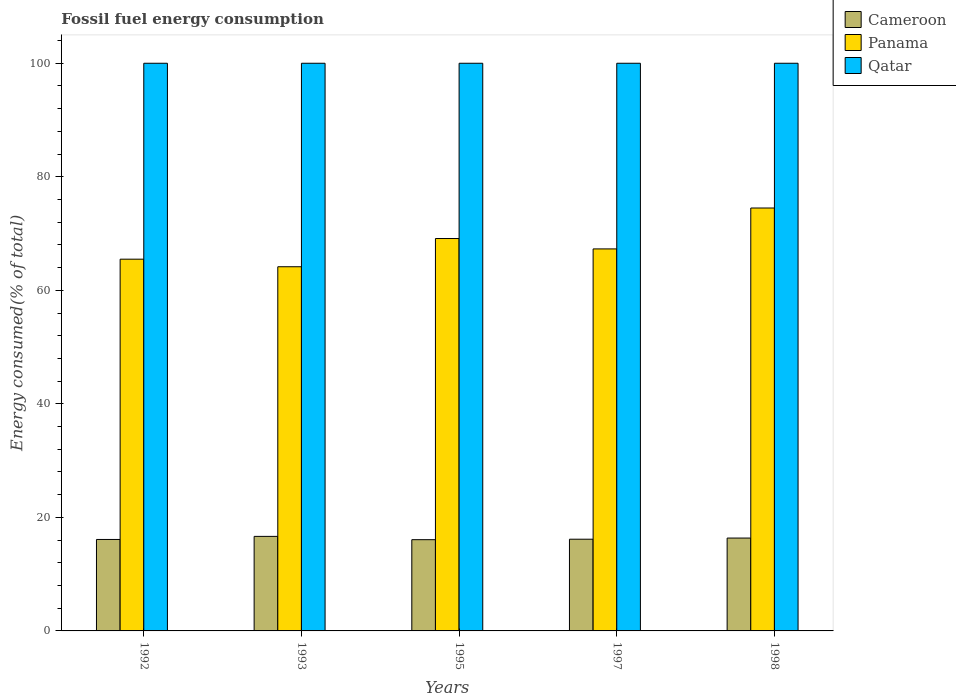Are the number of bars per tick equal to the number of legend labels?
Provide a short and direct response. Yes. Are the number of bars on each tick of the X-axis equal?
Offer a very short reply. Yes. What is the percentage of energy consumed in Panama in 1992?
Keep it short and to the point. 65.49. Across all years, what is the maximum percentage of energy consumed in Qatar?
Provide a succinct answer. 100. Across all years, what is the minimum percentage of energy consumed in Panama?
Provide a short and direct response. 64.15. In which year was the percentage of energy consumed in Qatar minimum?
Offer a very short reply. 1992. What is the total percentage of energy consumed in Panama in the graph?
Offer a terse response. 340.56. What is the difference between the percentage of energy consumed in Qatar in 1993 and that in 1997?
Ensure brevity in your answer.  -2.934021892997407e-6. What is the difference between the percentage of energy consumed in Cameroon in 1998 and the percentage of energy consumed in Panama in 1995?
Your answer should be very brief. -52.77. What is the average percentage of energy consumed in Panama per year?
Ensure brevity in your answer.  68.11. In the year 1995, what is the difference between the percentage of energy consumed in Panama and percentage of energy consumed in Cameroon?
Make the answer very short. 53.05. What is the ratio of the percentage of energy consumed in Panama in 1992 to that in 1993?
Make the answer very short. 1.02. Is the difference between the percentage of energy consumed in Panama in 1995 and 1997 greater than the difference between the percentage of energy consumed in Cameroon in 1995 and 1997?
Offer a terse response. Yes. What is the difference between the highest and the second highest percentage of energy consumed in Panama?
Make the answer very short. 5.37. What is the difference between the highest and the lowest percentage of energy consumed in Qatar?
Your answer should be very brief. 1.3242568797977583e-5. What does the 3rd bar from the left in 1995 represents?
Your answer should be compact. Qatar. What does the 2nd bar from the right in 1993 represents?
Offer a very short reply. Panama. Are all the bars in the graph horizontal?
Your response must be concise. No. Does the graph contain any zero values?
Your answer should be very brief. No. Does the graph contain grids?
Keep it short and to the point. No. Where does the legend appear in the graph?
Your answer should be compact. Top right. How many legend labels are there?
Make the answer very short. 3. What is the title of the graph?
Your answer should be very brief. Fossil fuel energy consumption. Does "Uruguay" appear as one of the legend labels in the graph?
Make the answer very short. No. What is the label or title of the X-axis?
Your response must be concise. Years. What is the label or title of the Y-axis?
Offer a terse response. Energy consumed(% of total). What is the Energy consumed(% of total) of Cameroon in 1992?
Your answer should be compact. 16.11. What is the Energy consumed(% of total) of Panama in 1992?
Offer a very short reply. 65.49. What is the Energy consumed(% of total) in Qatar in 1992?
Offer a very short reply. 100. What is the Energy consumed(% of total) of Cameroon in 1993?
Provide a short and direct response. 16.65. What is the Energy consumed(% of total) of Panama in 1993?
Your response must be concise. 64.15. What is the Energy consumed(% of total) in Qatar in 1993?
Your answer should be very brief. 100. What is the Energy consumed(% of total) in Cameroon in 1995?
Your response must be concise. 16.07. What is the Energy consumed(% of total) in Panama in 1995?
Make the answer very short. 69.13. What is the Energy consumed(% of total) of Qatar in 1995?
Your answer should be compact. 100. What is the Energy consumed(% of total) in Cameroon in 1997?
Your answer should be very brief. 16.15. What is the Energy consumed(% of total) in Panama in 1997?
Offer a terse response. 67.3. What is the Energy consumed(% of total) in Qatar in 1997?
Give a very brief answer. 100. What is the Energy consumed(% of total) of Cameroon in 1998?
Offer a very short reply. 16.36. What is the Energy consumed(% of total) in Panama in 1998?
Your response must be concise. 74.5. Across all years, what is the maximum Energy consumed(% of total) of Cameroon?
Offer a very short reply. 16.65. Across all years, what is the maximum Energy consumed(% of total) of Panama?
Keep it short and to the point. 74.5. Across all years, what is the maximum Energy consumed(% of total) of Qatar?
Offer a very short reply. 100. Across all years, what is the minimum Energy consumed(% of total) of Cameroon?
Your answer should be compact. 16.07. Across all years, what is the minimum Energy consumed(% of total) of Panama?
Your answer should be compact. 64.15. Across all years, what is the minimum Energy consumed(% of total) in Qatar?
Offer a very short reply. 100. What is the total Energy consumed(% of total) of Cameroon in the graph?
Your answer should be very brief. 81.35. What is the total Energy consumed(% of total) in Panama in the graph?
Provide a short and direct response. 340.56. What is the difference between the Energy consumed(% of total) of Cameroon in 1992 and that in 1993?
Keep it short and to the point. -0.54. What is the difference between the Energy consumed(% of total) of Panama in 1992 and that in 1993?
Ensure brevity in your answer.  1.33. What is the difference between the Energy consumed(% of total) of Cameroon in 1992 and that in 1995?
Give a very brief answer. 0.04. What is the difference between the Energy consumed(% of total) in Panama in 1992 and that in 1995?
Your answer should be very brief. -3.64. What is the difference between the Energy consumed(% of total) of Qatar in 1992 and that in 1995?
Offer a terse response. -0. What is the difference between the Energy consumed(% of total) of Cameroon in 1992 and that in 1997?
Offer a terse response. -0.04. What is the difference between the Energy consumed(% of total) of Panama in 1992 and that in 1997?
Offer a terse response. -1.81. What is the difference between the Energy consumed(% of total) in Cameroon in 1992 and that in 1998?
Your response must be concise. -0.25. What is the difference between the Energy consumed(% of total) in Panama in 1992 and that in 1998?
Keep it short and to the point. -9.01. What is the difference between the Energy consumed(% of total) of Qatar in 1992 and that in 1998?
Ensure brevity in your answer.  -0. What is the difference between the Energy consumed(% of total) in Cameroon in 1993 and that in 1995?
Provide a succinct answer. 0.58. What is the difference between the Energy consumed(% of total) in Panama in 1993 and that in 1995?
Your response must be concise. -4.97. What is the difference between the Energy consumed(% of total) of Cameroon in 1993 and that in 1997?
Ensure brevity in your answer.  0.5. What is the difference between the Energy consumed(% of total) of Panama in 1993 and that in 1997?
Make the answer very short. -3.14. What is the difference between the Energy consumed(% of total) in Qatar in 1993 and that in 1997?
Your answer should be compact. -0. What is the difference between the Energy consumed(% of total) in Cameroon in 1993 and that in 1998?
Your answer should be compact. 0.29. What is the difference between the Energy consumed(% of total) in Panama in 1993 and that in 1998?
Provide a short and direct response. -10.35. What is the difference between the Energy consumed(% of total) of Qatar in 1993 and that in 1998?
Make the answer very short. -0. What is the difference between the Energy consumed(% of total) of Cameroon in 1995 and that in 1997?
Your response must be concise. -0.08. What is the difference between the Energy consumed(% of total) in Panama in 1995 and that in 1997?
Provide a succinct answer. 1.83. What is the difference between the Energy consumed(% of total) of Cameroon in 1995 and that in 1998?
Provide a short and direct response. -0.29. What is the difference between the Energy consumed(% of total) in Panama in 1995 and that in 1998?
Provide a short and direct response. -5.37. What is the difference between the Energy consumed(% of total) of Cameroon in 1997 and that in 1998?
Offer a very short reply. -0.21. What is the difference between the Energy consumed(% of total) in Panama in 1997 and that in 1998?
Your answer should be compact. -7.2. What is the difference between the Energy consumed(% of total) of Cameroon in 1992 and the Energy consumed(% of total) of Panama in 1993?
Offer a terse response. -48.04. What is the difference between the Energy consumed(% of total) of Cameroon in 1992 and the Energy consumed(% of total) of Qatar in 1993?
Keep it short and to the point. -83.89. What is the difference between the Energy consumed(% of total) in Panama in 1992 and the Energy consumed(% of total) in Qatar in 1993?
Make the answer very short. -34.51. What is the difference between the Energy consumed(% of total) in Cameroon in 1992 and the Energy consumed(% of total) in Panama in 1995?
Ensure brevity in your answer.  -53.02. What is the difference between the Energy consumed(% of total) of Cameroon in 1992 and the Energy consumed(% of total) of Qatar in 1995?
Offer a terse response. -83.89. What is the difference between the Energy consumed(% of total) of Panama in 1992 and the Energy consumed(% of total) of Qatar in 1995?
Give a very brief answer. -34.51. What is the difference between the Energy consumed(% of total) in Cameroon in 1992 and the Energy consumed(% of total) in Panama in 1997?
Offer a terse response. -51.19. What is the difference between the Energy consumed(% of total) of Cameroon in 1992 and the Energy consumed(% of total) of Qatar in 1997?
Your response must be concise. -83.89. What is the difference between the Energy consumed(% of total) in Panama in 1992 and the Energy consumed(% of total) in Qatar in 1997?
Offer a very short reply. -34.51. What is the difference between the Energy consumed(% of total) in Cameroon in 1992 and the Energy consumed(% of total) in Panama in 1998?
Keep it short and to the point. -58.39. What is the difference between the Energy consumed(% of total) of Cameroon in 1992 and the Energy consumed(% of total) of Qatar in 1998?
Provide a succinct answer. -83.89. What is the difference between the Energy consumed(% of total) in Panama in 1992 and the Energy consumed(% of total) in Qatar in 1998?
Provide a succinct answer. -34.51. What is the difference between the Energy consumed(% of total) in Cameroon in 1993 and the Energy consumed(% of total) in Panama in 1995?
Keep it short and to the point. -52.47. What is the difference between the Energy consumed(% of total) in Cameroon in 1993 and the Energy consumed(% of total) in Qatar in 1995?
Your answer should be very brief. -83.35. What is the difference between the Energy consumed(% of total) in Panama in 1993 and the Energy consumed(% of total) in Qatar in 1995?
Offer a terse response. -35.85. What is the difference between the Energy consumed(% of total) of Cameroon in 1993 and the Energy consumed(% of total) of Panama in 1997?
Make the answer very short. -50.64. What is the difference between the Energy consumed(% of total) in Cameroon in 1993 and the Energy consumed(% of total) in Qatar in 1997?
Your answer should be very brief. -83.35. What is the difference between the Energy consumed(% of total) in Panama in 1993 and the Energy consumed(% of total) in Qatar in 1997?
Your answer should be very brief. -35.85. What is the difference between the Energy consumed(% of total) of Cameroon in 1993 and the Energy consumed(% of total) of Panama in 1998?
Ensure brevity in your answer.  -57.85. What is the difference between the Energy consumed(% of total) in Cameroon in 1993 and the Energy consumed(% of total) in Qatar in 1998?
Your response must be concise. -83.35. What is the difference between the Energy consumed(% of total) in Panama in 1993 and the Energy consumed(% of total) in Qatar in 1998?
Offer a terse response. -35.85. What is the difference between the Energy consumed(% of total) of Cameroon in 1995 and the Energy consumed(% of total) of Panama in 1997?
Offer a terse response. -51.22. What is the difference between the Energy consumed(% of total) of Cameroon in 1995 and the Energy consumed(% of total) of Qatar in 1997?
Make the answer very short. -83.93. What is the difference between the Energy consumed(% of total) in Panama in 1995 and the Energy consumed(% of total) in Qatar in 1997?
Ensure brevity in your answer.  -30.87. What is the difference between the Energy consumed(% of total) of Cameroon in 1995 and the Energy consumed(% of total) of Panama in 1998?
Give a very brief answer. -58.43. What is the difference between the Energy consumed(% of total) in Cameroon in 1995 and the Energy consumed(% of total) in Qatar in 1998?
Your response must be concise. -83.93. What is the difference between the Energy consumed(% of total) of Panama in 1995 and the Energy consumed(% of total) of Qatar in 1998?
Make the answer very short. -30.87. What is the difference between the Energy consumed(% of total) of Cameroon in 1997 and the Energy consumed(% of total) of Panama in 1998?
Provide a succinct answer. -58.35. What is the difference between the Energy consumed(% of total) in Cameroon in 1997 and the Energy consumed(% of total) in Qatar in 1998?
Offer a terse response. -83.85. What is the difference between the Energy consumed(% of total) in Panama in 1997 and the Energy consumed(% of total) in Qatar in 1998?
Give a very brief answer. -32.7. What is the average Energy consumed(% of total) in Cameroon per year?
Keep it short and to the point. 16.27. What is the average Energy consumed(% of total) of Panama per year?
Keep it short and to the point. 68.11. What is the average Energy consumed(% of total) in Qatar per year?
Ensure brevity in your answer.  100. In the year 1992, what is the difference between the Energy consumed(% of total) in Cameroon and Energy consumed(% of total) in Panama?
Your response must be concise. -49.37. In the year 1992, what is the difference between the Energy consumed(% of total) of Cameroon and Energy consumed(% of total) of Qatar?
Offer a terse response. -83.89. In the year 1992, what is the difference between the Energy consumed(% of total) of Panama and Energy consumed(% of total) of Qatar?
Your answer should be very brief. -34.51. In the year 1993, what is the difference between the Energy consumed(% of total) of Cameroon and Energy consumed(% of total) of Panama?
Your response must be concise. -47.5. In the year 1993, what is the difference between the Energy consumed(% of total) in Cameroon and Energy consumed(% of total) in Qatar?
Make the answer very short. -83.35. In the year 1993, what is the difference between the Energy consumed(% of total) of Panama and Energy consumed(% of total) of Qatar?
Your response must be concise. -35.85. In the year 1995, what is the difference between the Energy consumed(% of total) in Cameroon and Energy consumed(% of total) in Panama?
Make the answer very short. -53.05. In the year 1995, what is the difference between the Energy consumed(% of total) of Cameroon and Energy consumed(% of total) of Qatar?
Offer a terse response. -83.93. In the year 1995, what is the difference between the Energy consumed(% of total) of Panama and Energy consumed(% of total) of Qatar?
Give a very brief answer. -30.87. In the year 1997, what is the difference between the Energy consumed(% of total) of Cameroon and Energy consumed(% of total) of Panama?
Keep it short and to the point. -51.14. In the year 1997, what is the difference between the Energy consumed(% of total) of Cameroon and Energy consumed(% of total) of Qatar?
Give a very brief answer. -83.85. In the year 1997, what is the difference between the Energy consumed(% of total) in Panama and Energy consumed(% of total) in Qatar?
Provide a short and direct response. -32.7. In the year 1998, what is the difference between the Energy consumed(% of total) of Cameroon and Energy consumed(% of total) of Panama?
Provide a succinct answer. -58.14. In the year 1998, what is the difference between the Energy consumed(% of total) in Cameroon and Energy consumed(% of total) in Qatar?
Provide a short and direct response. -83.64. In the year 1998, what is the difference between the Energy consumed(% of total) in Panama and Energy consumed(% of total) in Qatar?
Provide a short and direct response. -25.5. What is the ratio of the Energy consumed(% of total) in Cameroon in 1992 to that in 1993?
Keep it short and to the point. 0.97. What is the ratio of the Energy consumed(% of total) of Panama in 1992 to that in 1993?
Keep it short and to the point. 1.02. What is the ratio of the Energy consumed(% of total) of Qatar in 1992 to that in 1993?
Your answer should be very brief. 1. What is the ratio of the Energy consumed(% of total) in Panama in 1992 to that in 1995?
Offer a very short reply. 0.95. What is the ratio of the Energy consumed(% of total) of Qatar in 1992 to that in 1995?
Your answer should be very brief. 1. What is the ratio of the Energy consumed(% of total) of Panama in 1992 to that in 1997?
Offer a very short reply. 0.97. What is the ratio of the Energy consumed(% of total) of Qatar in 1992 to that in 1997?
Your answer should be very brief. 1. What is the ratio of the Energy consumed(% of total) of Cameroon in 1992 to that in 1998?
Make the answer very short. 0.98. What is the ratio of the Energy consumed(% of total) in Panama in 1992 to that in 1998?
Make the answer very short. 0.88. What is the ratio of the Energy consumed(% of total) in Qatar in 1992 to that in 1998?
Provide a short and direct response. 1. What is the ratio of the Energy consumed(% of total) in Cameroon in 1993 to that in 1995?
Provide a succinct answer. 1.04. What is the ratio of the Energy consumed(% of total) of Panama in 1993 to that in 1995?
Provide a short and direct response. 0.93. What is the ratio of the Energy consumed(% of total) of Cameroon in 1993 to that in 1997?
Give a very brief answer. 1.03. What is the ratio of the Energy consumed(% of total) in Panama in 1993 to that in 1997?
Your response must be concise. 0.95. What is the ratio of the Energy consumed(% of total) of Panama in 1993 to that in 1998?
Offer a very short reply. 0.86. What is the ratio of the Energy consumed(% of total) of Cameroon in 1995 to that in 1997?
Ensure brevity in your answer.  0.99. What is the ratio of the Energy consumed(% of total) of Panama in 1995 to that in 1997?
Offer a very short reply. 1.03. What is the ratio of the Energy consumed(% of total) of Qatar in 1995 to that in 1997?
Offer a very short reply. 1. What is the ratio of the Energy consumed(% of total) in Cameroon in 1995 to that in 1998?
Keep it short and to the point. 0.98. What is the ratio of the Energy consumed(% of total) of Panama in 1995 to that in 1998?
Make the answer very short. 0.93. What is the ratio of the Energy consumed(% of total) of Cameroon in 1997 to that in 1998?
Keep it short and to the point. 0.99. What is the ratio of the Energy consumed(% of total) of Panama in 1997 to that in 1998?
Offer a very short reply. 0.9. What is the ratio of the Energy consumed(% of total) of Qatar in 1997 to that in 1998?
Keep it short and to the point. 1. What is the difference between the highest and the second highest Energy consumed(% of total) of Cameroon?
Your answer should be very brief. 0.29. What is the difference between the highest and the second highest Energy consumed(% of total) of Panama?
Provide a short and direct response. 5.37. What is the difference between the highest and the lowest Energy consumed(% of total) in Cameroon?
Make the answer very short. 0.58. What is the difference between the highest and the lowest Energy consumed(% of total) in Panama?
Offer a very short reply. 10.35. What is the difference between the highest and the lowest Energy consumed(% of total) in Qatar?
Keep it short and to the point. 0. 